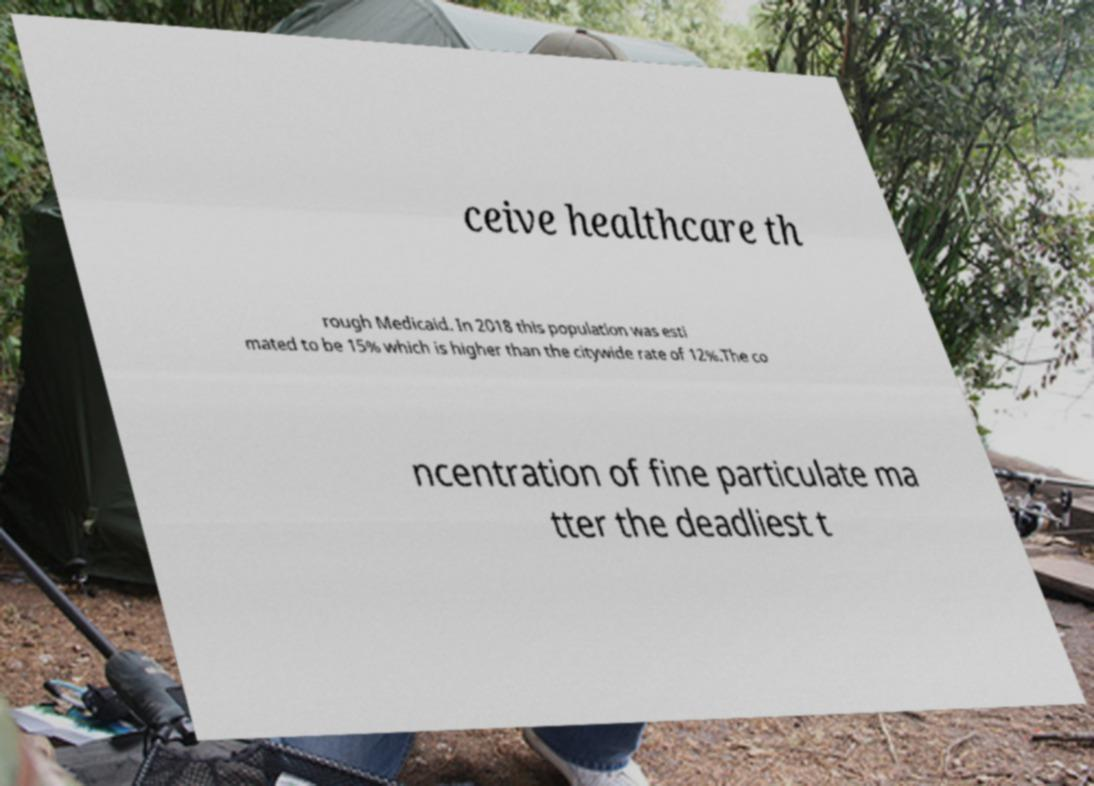What messages or text are displayed in this image? I need them in a readable, typed format. ceive healthcare th rough Medicaid. In 2018 this population was esti mated to be 15% which is higher than the citywide rate of 12%.The co ncentration of fine particulate ma tter the deadliest t 